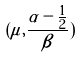<formula> <loc_0><loc_0><loc_500><loc_500>( \mu , \frac { \alpha - \frac { 1 } { 2 } } { \beta } )</formula> 